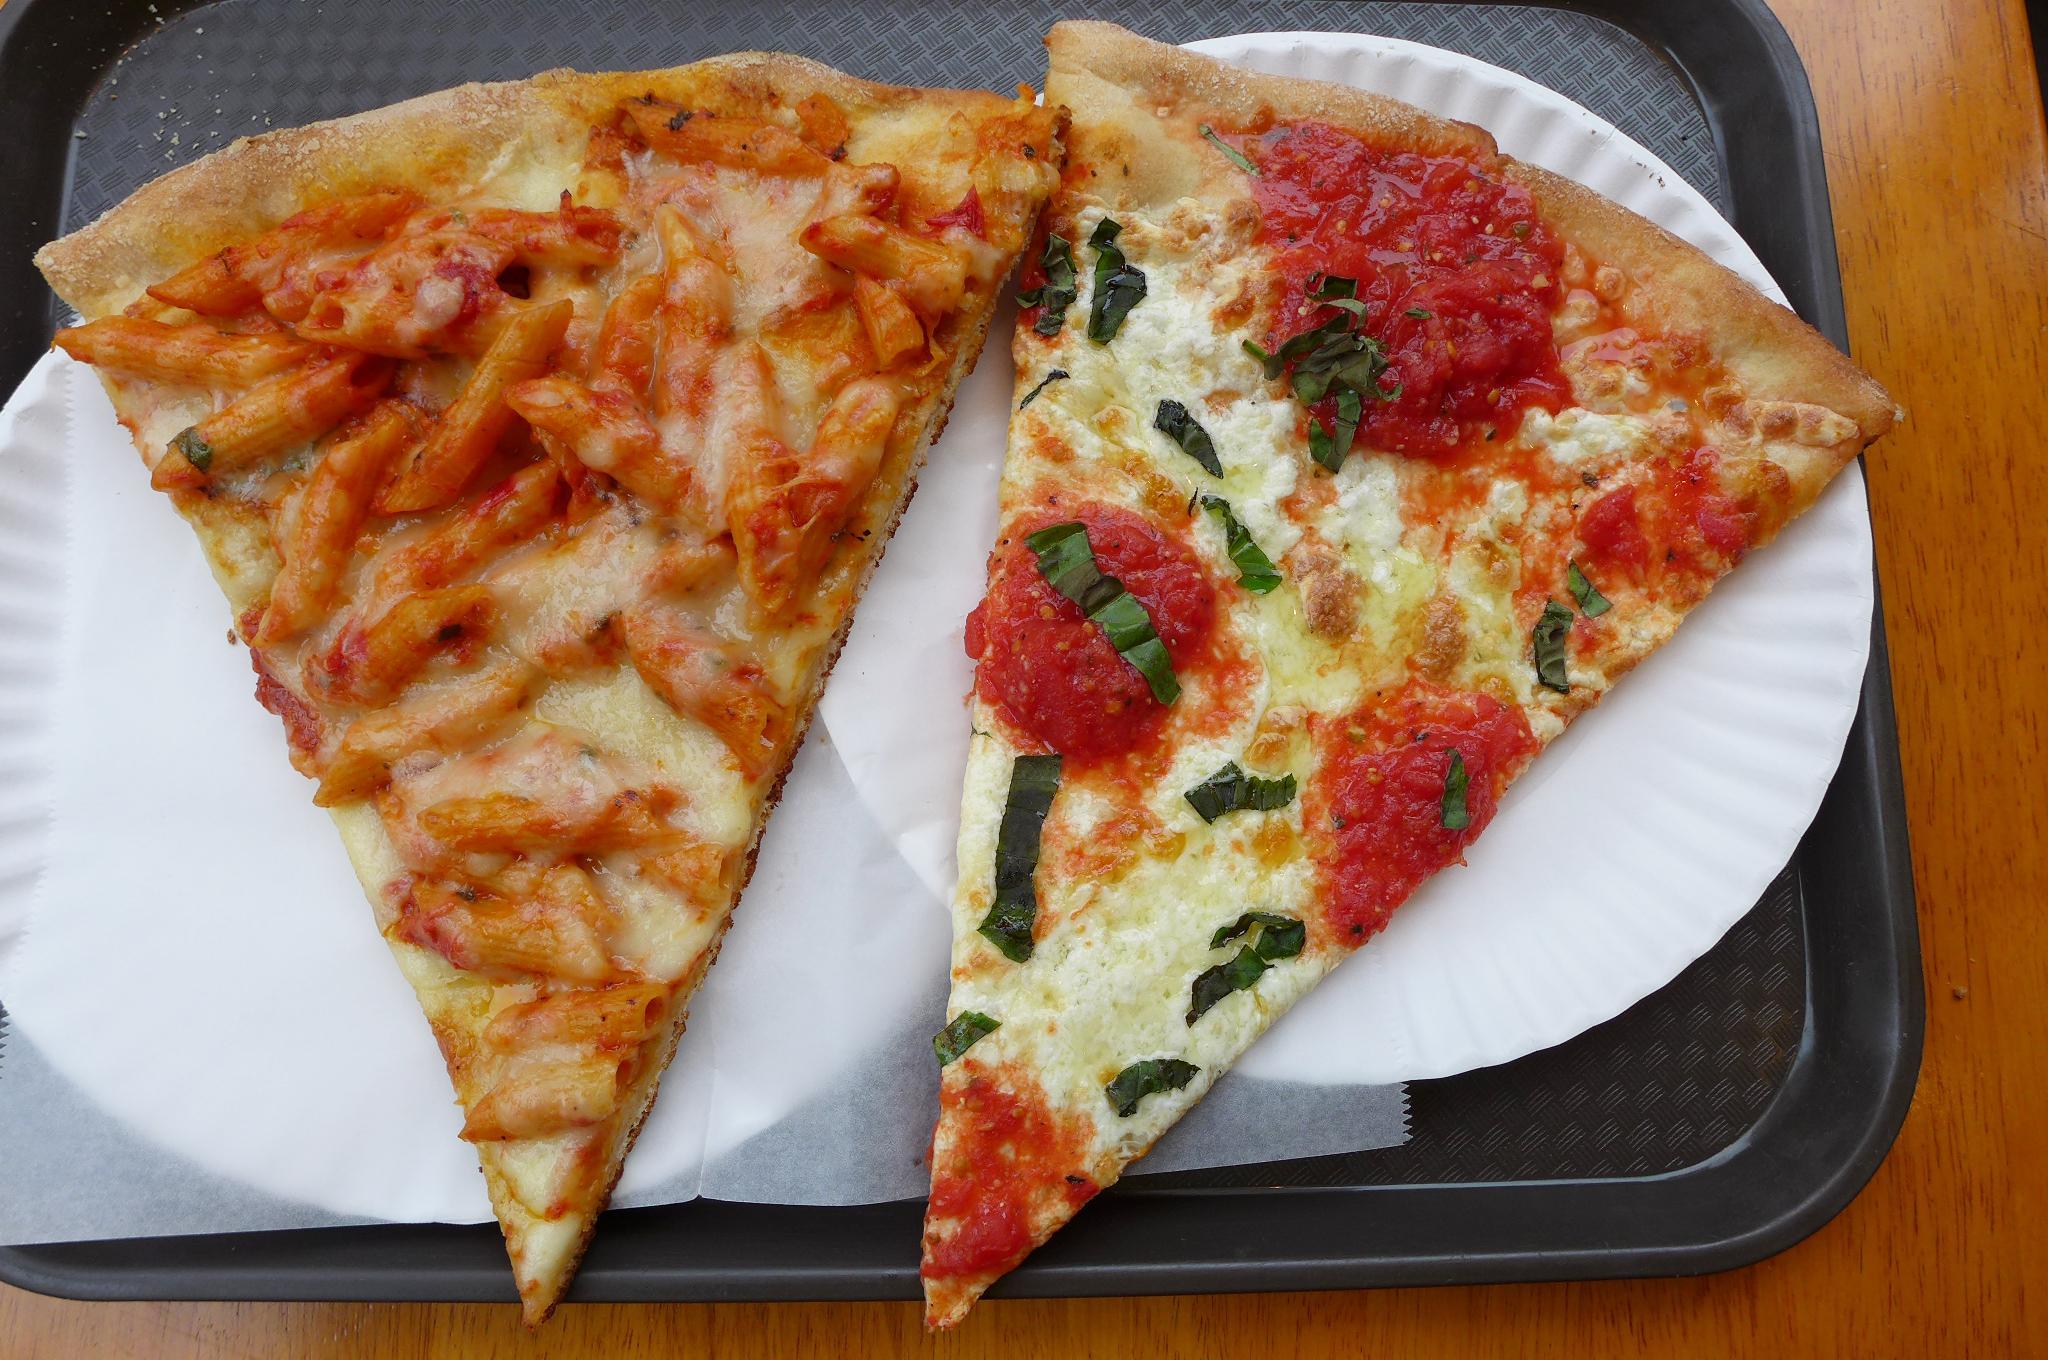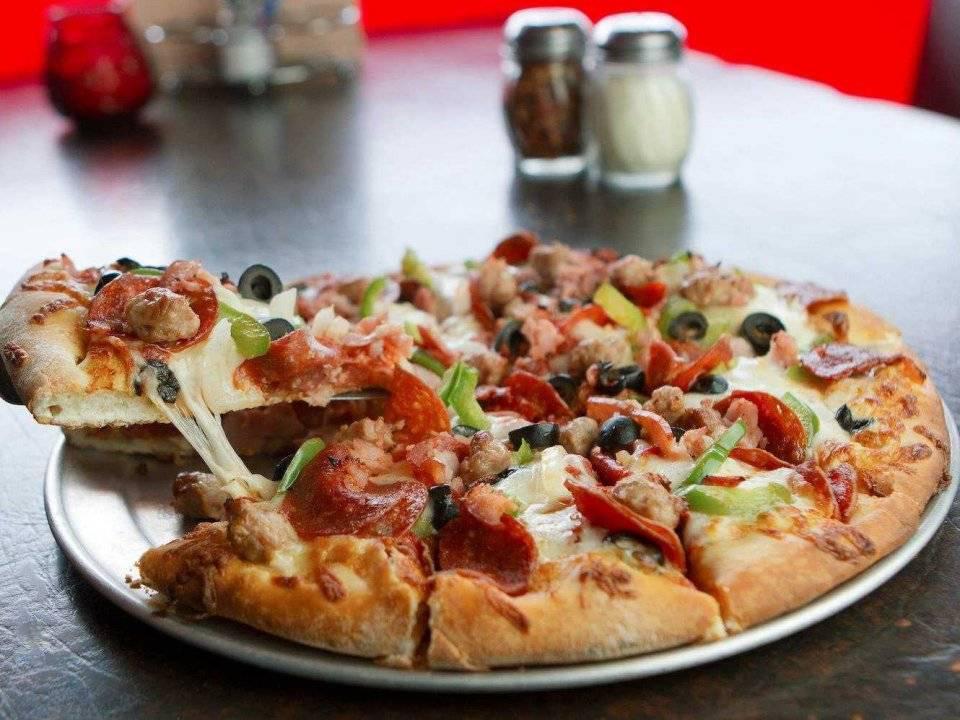The first image is the image on the left, the second image is the image on the right. Examine the images to the left and right. Is the description "The right image shows one slice of a round pizza separated by a small distance from the rest." accurate? Answer yes or no. Yes. 